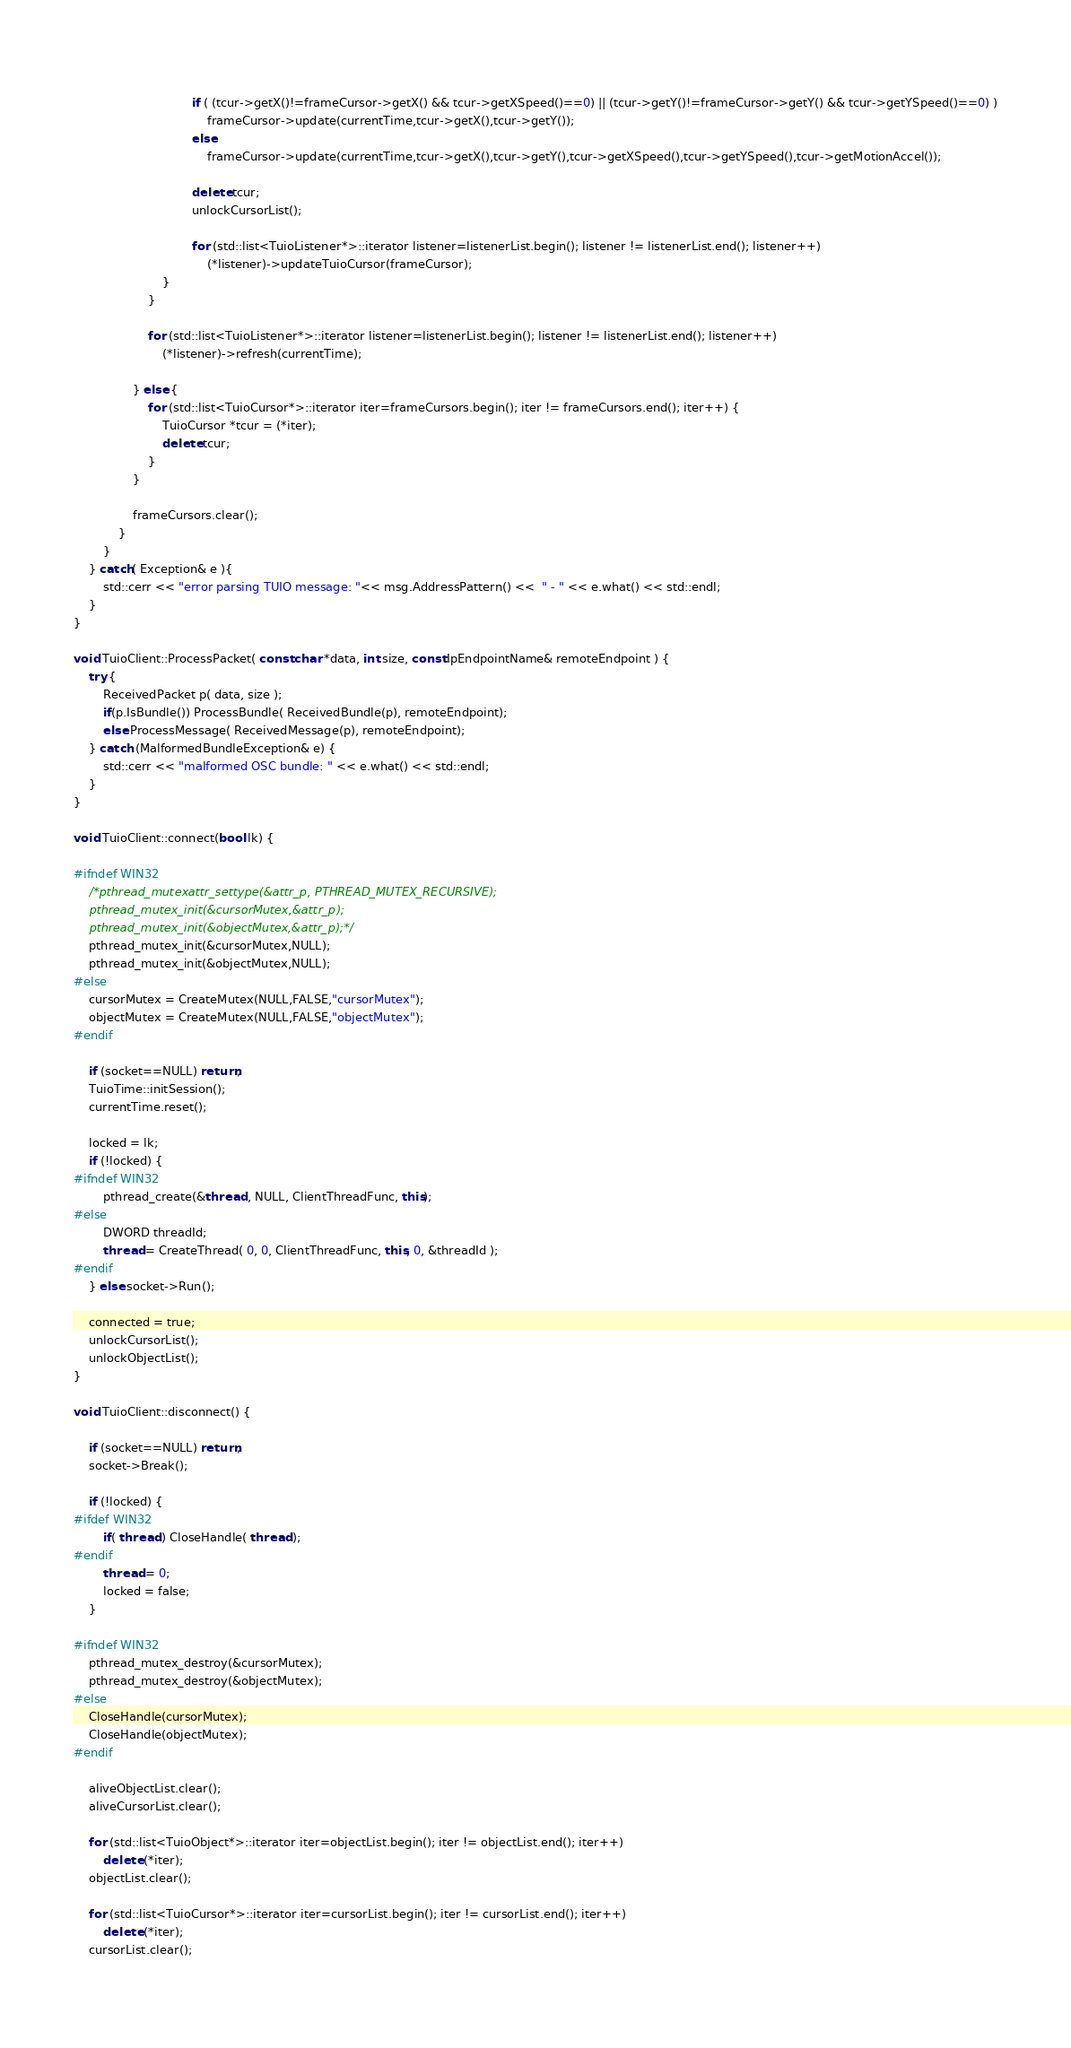Convert code to text. <code><loc_0><loc_0><loc_500><loc_500><_C++_>								
								if ( (tcur->getX()!=frameCursor->getX() && tcur->getXSpeed()==0) || (tcur->getY()!=frameCursor->getY() && tcur->getYSpeed()==0) )
									frameCursor->update(currentTime,tcur->getX(),tcur->getY());
								else
									frameCursor->update(currentTime,tcur->getX(),tcur->getY(),tcur->getXSpeed(),tcur->getYSpeed(),tcur->getMotionAccel());
						
								delete tcur;
								unlockCursorList();
								
								for (std::list<TuioListener*>::iterator listener=listenerList.begin(); listener != listenerList.end(); listener++)
									(*listener)->updateTuioCursor(frameCursor);
						}	
					}
					
					for (std::list<TuioListener*>::iterator listener=listenerList.begin(); listener != listenerList.end(); listener++)
						(*listener)->refresh(currentTime);
					
				} else {
					for (std::list<TuioCursor*>::iterator iter=frameCursors.begin(); iter != frameCursors.end(); iter++) {
						TuioCursor *tcur = (*iter);
						delete tcur;
					}
				}
				
				frameCursors.clear();
			}
		}
	} catch( Exception& e ){
		std::cerr << "error parsing TUIO message: "<< msg.AddressPattern() <<  " - " << e.what() << std::endl;
	}
}

void TuioClient::ProcessPacket( const char *data, int size, const IpEndpointName& remoteEndpoint ) {
	try {
		ReceivedPacket p( data, size );
		if(p.IsBundle()) ProcessBundle( ReceivedBundle(p), remoteEndpoint);
		else ProcessMessage( ReceivedMessage(p), remoteEndpoint);
	} catch (MalformedBundleException& e) {
		std::cerr << "malformed OSC bundle: " << e.what() << std::endl;
	}
}

void TuioClient::connect(bool lk) {

#ifndef WIN32	
	/*pthread_mutexattr_settype(&attr_p, PTHREAD_MUTEX_RECURSIVE);
	pthread_mutex_init(&cursorMutex,&attr_p);
	pthread_mutex_init(&objectMutex,&attr_p);*/
	pthread_mutex_init(&cursorMutex,NULL);
	pthread_mutex_init(&objectMutex,NULL);	
#else
	cursorMutex = CreateMutex(NULL,FALSE,"cursorMutex");
	objectMutex = CreateMutex(NULL,FALSE,"objectMutex");
#endif		
		
	if (socket==NULL) return;
	TuioTime::initSession();
	currentTime.reset();
	
	locked = lk;
	if (!locked) {
#ifndef WIN32
		pthread_create(&thread , NULL, ClientThreadFunc, this);
#else
		DWORD threadId;
		thread = CreateThread( 0, 0, ClientThreadFunc, this, 0, &threadId );
#endif
	} else socket->Run();
	
	connected = true;
	unlockCursorList();
	unlockObjectList();
}

void TuioClient::disconnect() {
	
	if (socket==NULL) return;
	socket->Break();
	
	if (!locked) {
#ifdef WIN32
		if( thread ) CloseHandle( thread );
#endif
		thread = 0;
		locked = false;
	}
	
#ifndef WIN32	
	pthread_mutex_destroy(&cursorMutex);
	pthread_mutex_destroy(&objectMutex);
#else
	CloseHandle(cursorMutex);
	CloseHandle(objectMutex);
#endif

	aliveObjectList.clear();
	aliveCursorList.clear();

	for (std::list<TuioObject*>::iterator iter=objectList.begin(); iter != objectList.end(); iter++)
		delete (*iter);
	objectList.clear();

	for (std::list<TuioCursor*>::iterator iter=cursorList.begin(); iter != cursorList.end(); iter++)
		delete (*iter);
	cursorList.clear();
	</code> 